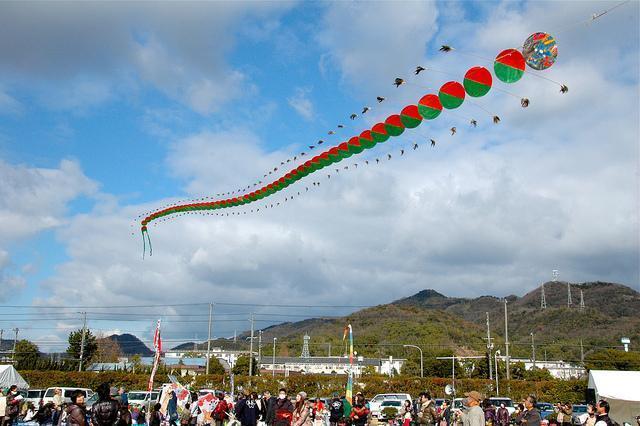How many kites are there?
Give a very brief answer. 1. How many legs does the dog have?
Give a very brief answer. 0. 